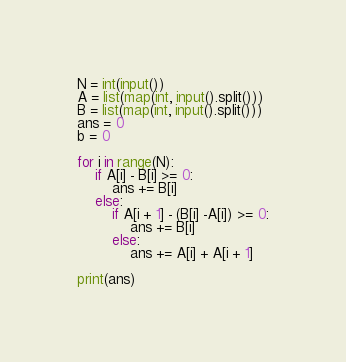Convert code to text. <code><loc_0><loc_0><loc_500><loc_500><_Python_>N = int(input())
A = list(map(int, input().split()))
B = list(map(int, input().split()))
ans = 0
b = 0

for i in range(N):
    if A[i] - B[i] >= 0:
        ans += B[i]
    else:
        if A[i + 1] - (B[i] -A[i]) >= 0:
            ans += B[i]
        else:
            ans += A[i] + A[i + 1]

print(ans)</code> 